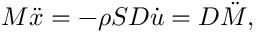Convert formula to latex. <formula><loc_0><loc_0><loc_500><loc_500>M \ddot { x } = - \rho S D \dot { u } = D \ddot { M } ,</formula> 